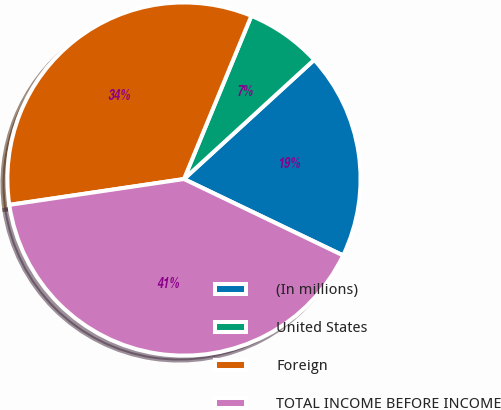Convert chart. <chart><loc_0><loc_0><loc_500><loc_500><pie_chart><fcel>(In millions)<fcel>United States<fcel>Foreign<fcel>TOTAL INCOME BEFORE INCOME<nl><fcel>18.92%<fcel>6.97%<fcel>33.57%<fcel>40.54%<nl></chart> 